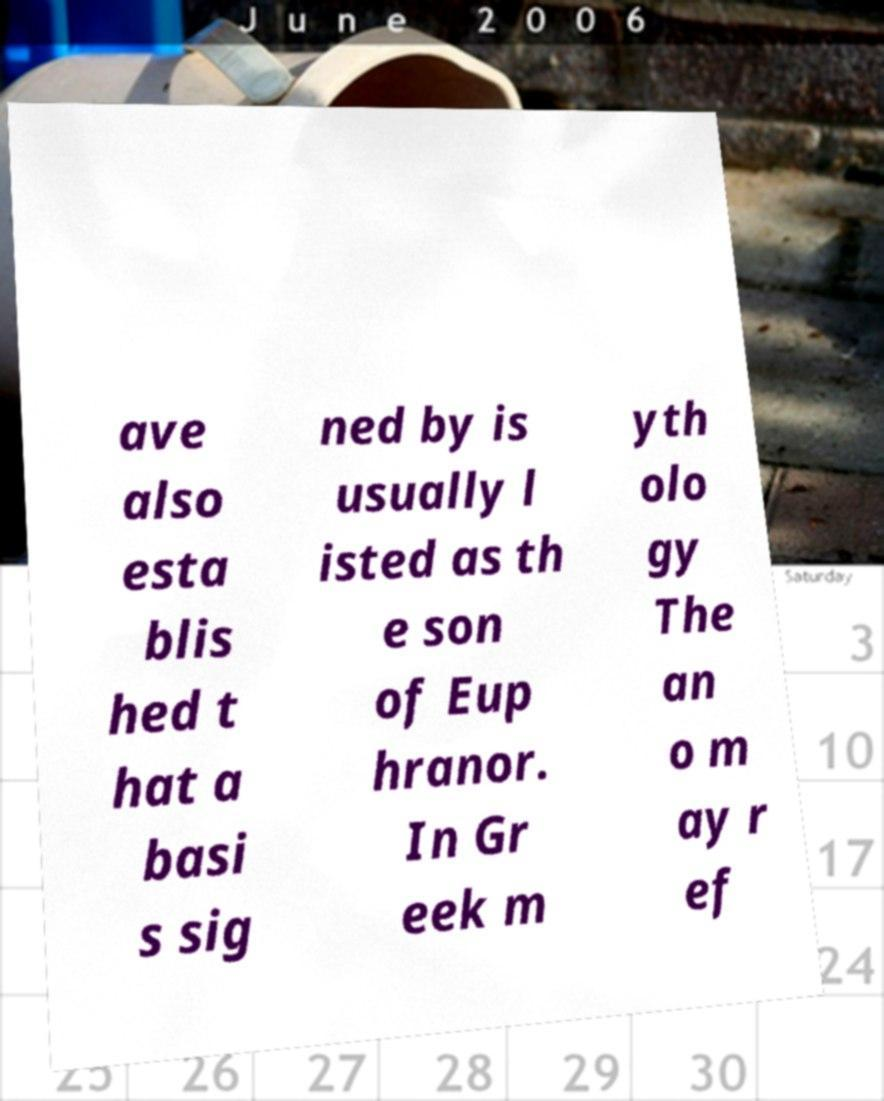I need the written content from this picture converted into text. Can you do that? ave also esta blis hed t hat a basi s sig ned by is usually l isted as th e son of Eup hranor. In Gr eek m yth olo gy The an o m ay r ef 